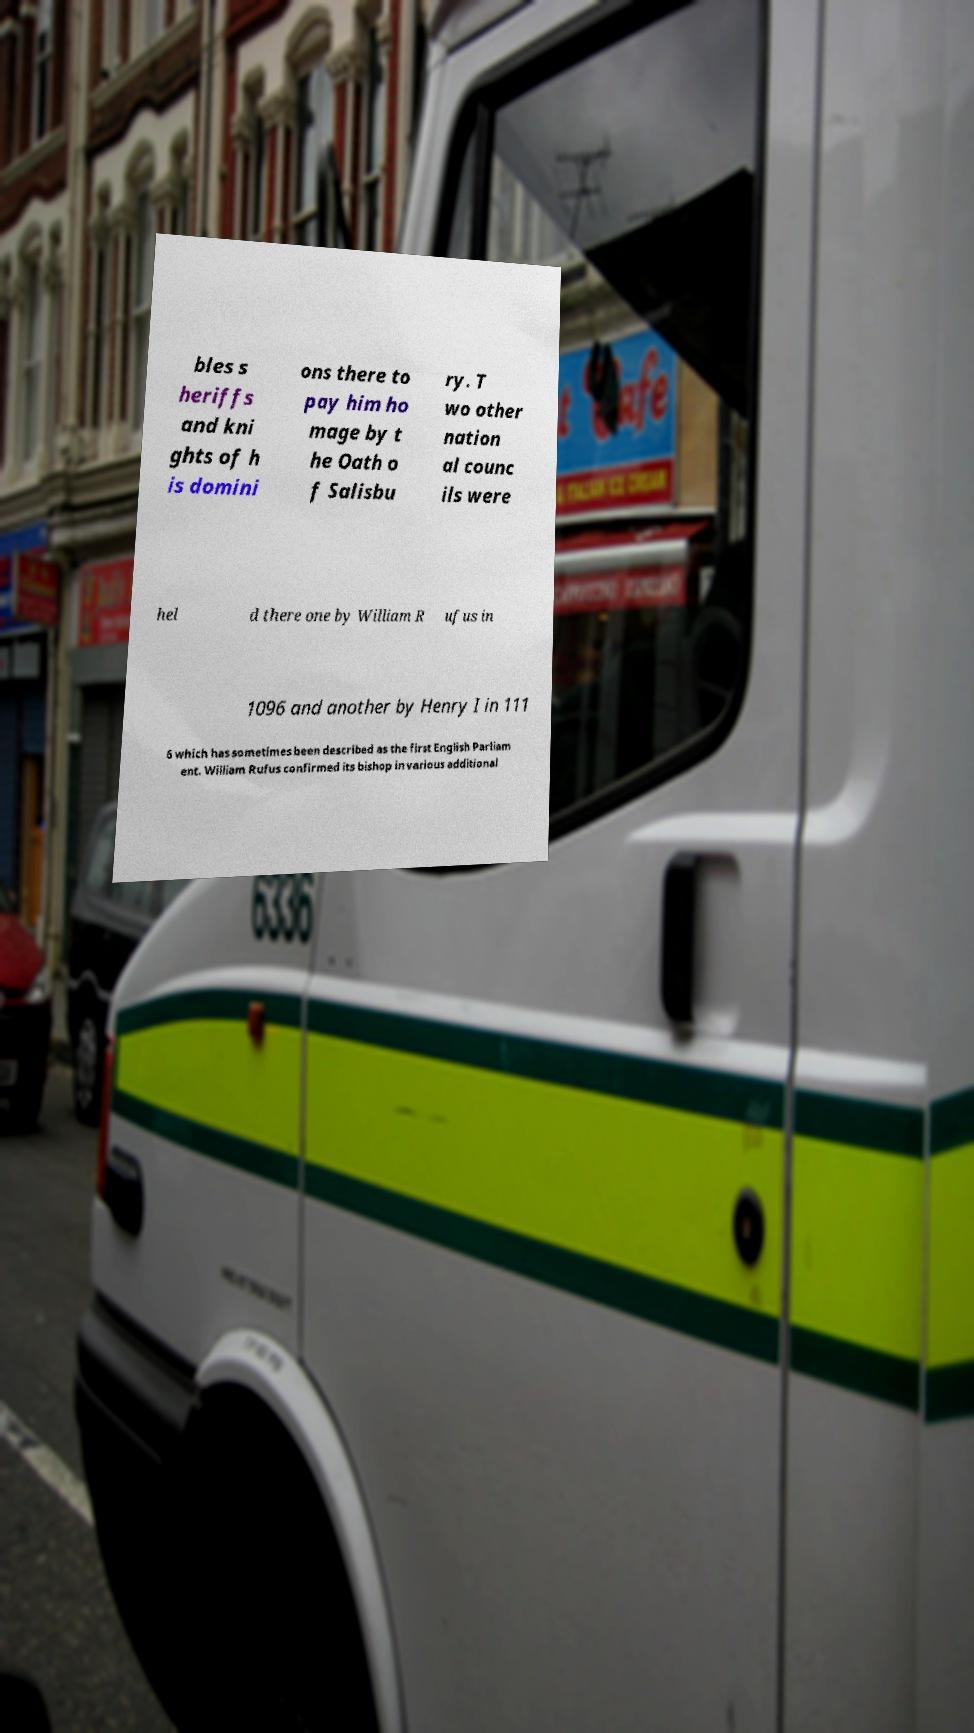Please read and relay the text visible in this image. What does it say? bles s heriffs and kni ghts of h is domini ons there to pay him ho mage by t he Oath o f Salisbu ry. T wo other nation al counc ils were hel d there one by William R ufus in 1096 and another by Henry I in 111 6 which has sometimes been described as the first English Parliam ent. William Rufus confirmed its bishop in various additional 